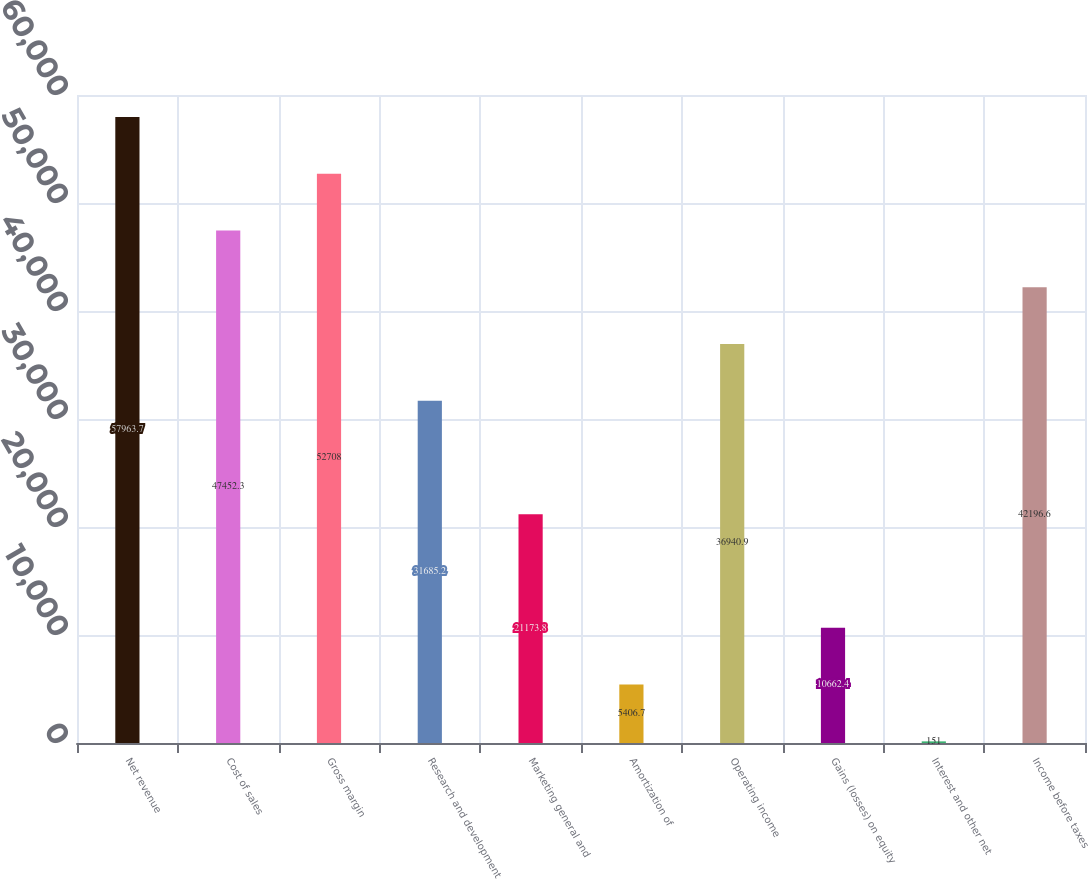<chart> <loc_0><loc_0><loc_500><loc_500><bar_chart><fcel>Net revenue<fcel>Cost of sales<fcel>Gross margin<fcel>Research and development<fcel>Marketing general and<fcel>Amortization of<fcel>Operating income<fcel>Gains (losses) on equity<fcel>Interest and other net<fcel>Income before taxes<nl><fcel>57963.7<fcel>47452.3<fcel>52708<fcel>31685.2<fcel>21173.8<fcel>5406.7<fcel>36940.9<fcel>10662.4<fcel>151<fcel>42196.6<nl></chart> 